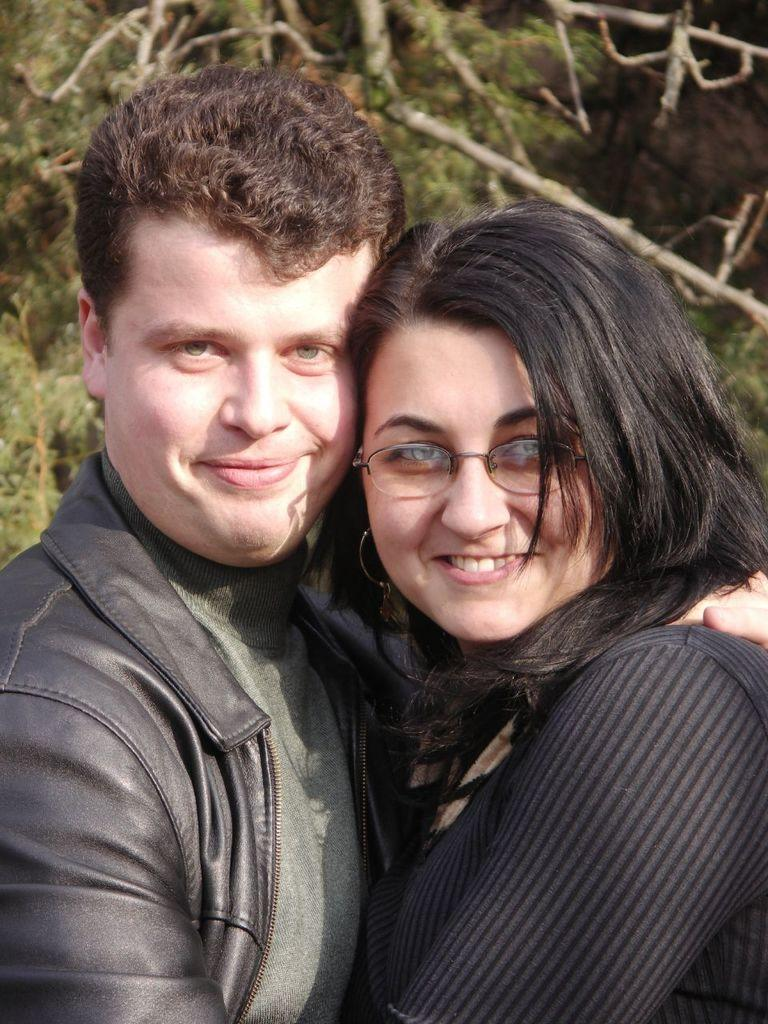How many people are in the image? There are two people standing in the image. What are the people doing in the image? The people are posing for a photo. What can be seen in the background of the image? There are many trees visible in the background of the image. Can you see any visible veins on the people in the image? There is no information about the visibility of veins on the people in the image, as the focus is on their posing for a photo and the background of trees. 